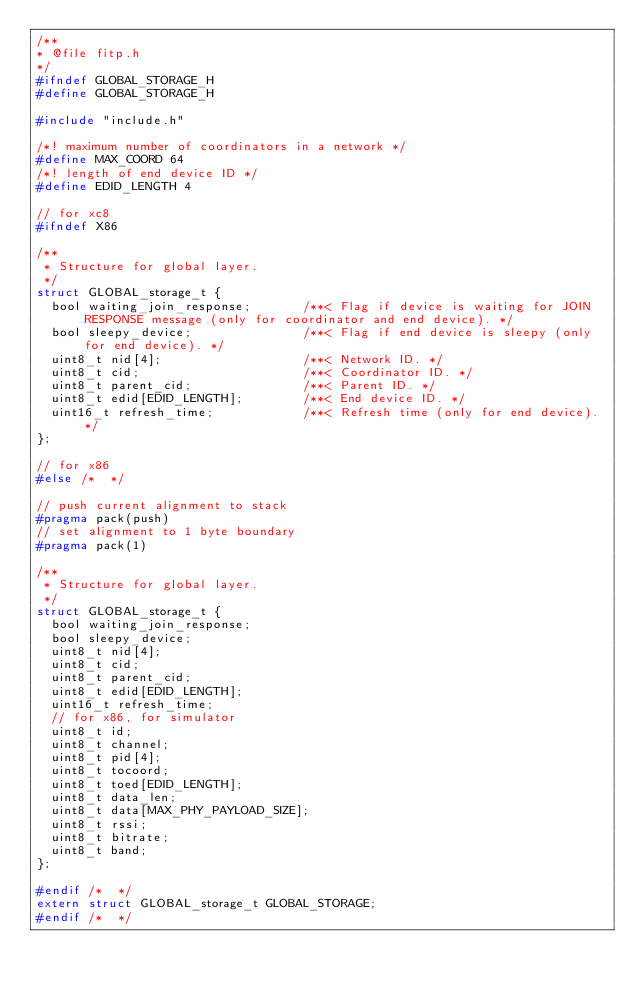Convert code to text. <code><loc_0><loc_0><loc_500><loc_500><_C_>/**
* @file fitp.h
*/
#ifndef GLOBAL_STORAGE_H
#define GLOBAL_STORAGE_H

#include "include.h"

/*! maximum number of coordinators in a network */
#define MAX_COORD 64
/*! length of end device ID */
#define EDID_LENGTH 4

// for xc8
#ifndef X86

/**
 * Structure for global layer.
 */
struct GLOBAL_storage_t {
	bool waiting_join_response;				/**< Flag if device is waiting for JOIN RESPONSE message (only for coordinator and end device). */
	bool sleepy_device;								/**< Flag if end device is sleepy (only for end device). */
	uint8_t nid[4];										/**< Network ID. */
	uint8_t cid;											/**< Coordinator ID. */
	uint8_t parent_cid;								/**< Parent ID. */
	uint8_t edid[EDID_LENGTH];				/**< End device ID. */
	uint16_t refresh_time;						/**< Refresh time (only for end device). */
};

// for x86
#else	/*  */

// push current alignment to stack
#pragma pack(push)
// set alignment to 1 byte boundary
#pragma pack(1)

/**
 * Structure for global layer.
 */
struct GLOBAL_storage_t {
	bool waiting_join_response;
	bool sleepy_device;
	uint8_t nid[4];
	uint8_t cid;
	uint8_t parent_cid;
	uint8_t edid[EDID_LENGTH];
	uint16_t refresh_time;
	// for x86, for simulator
	uint8_t id;
	uint8_t channel;
	uint8_t pid[4];
	uint8_t tocoord;
	uint8_t toed[EDID_LENGTH];
	uint8_t data_len;
	uint8_t data[MAX_PHY_PAYLOAD_SIZE];
	uint8_t rssi;
	uint8_t bitrate;
	uint8_t band;
};

#endif /*  */
extern struct GLOBAL_storage_t GLOBAL_STORAGE;
#endif /*  */
</code> 